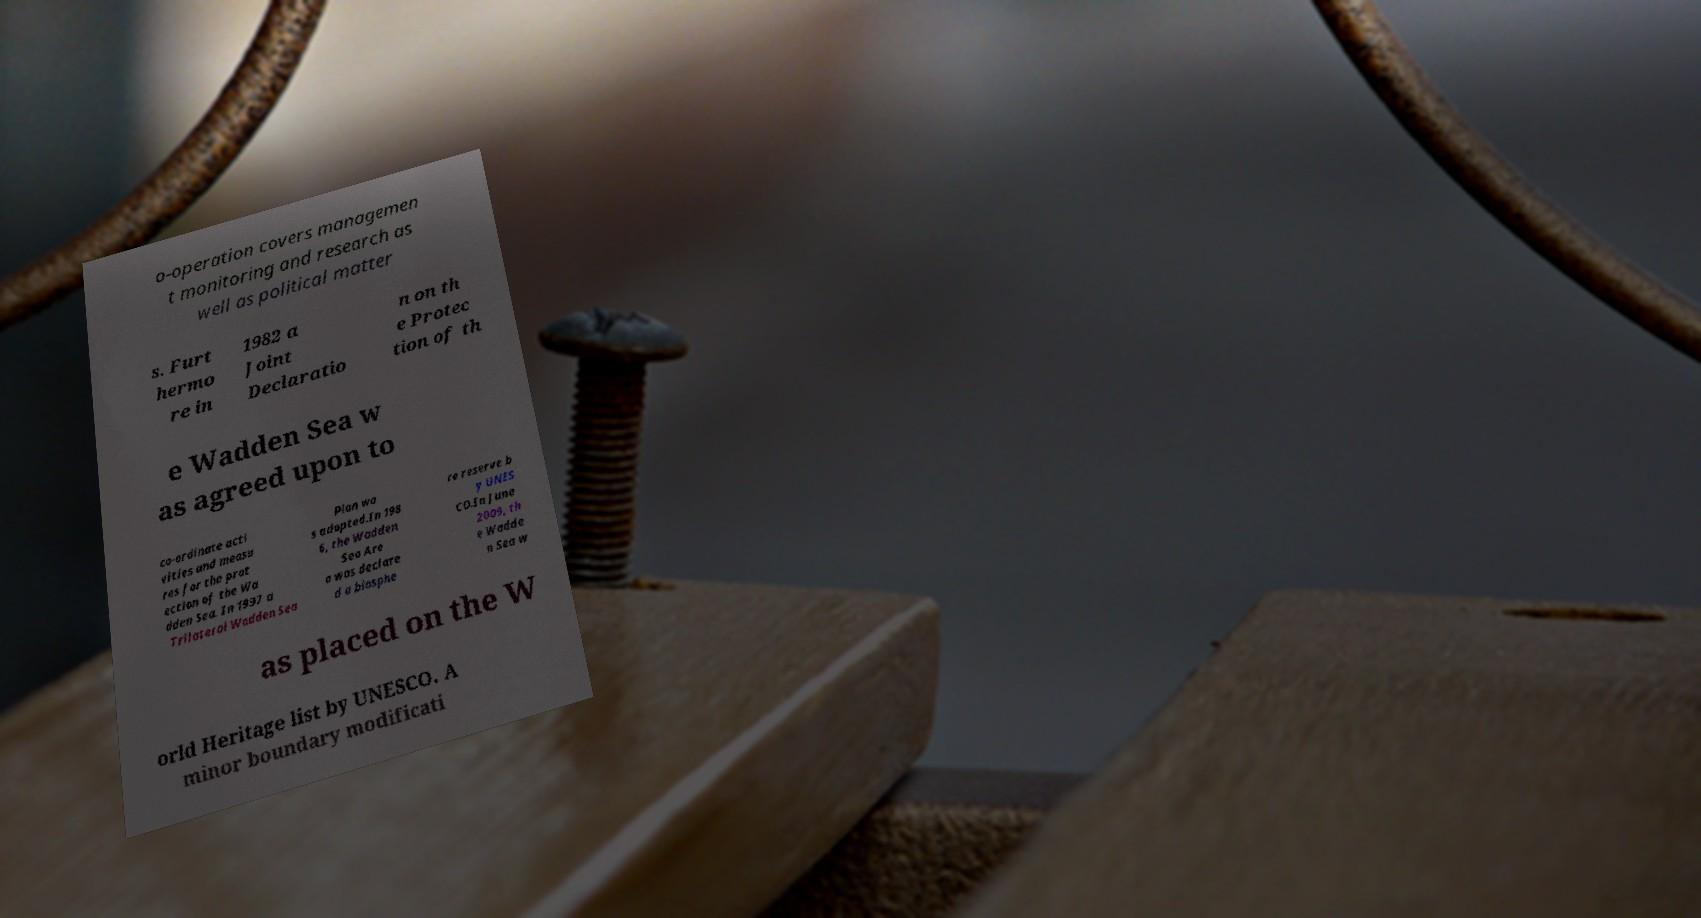What messages or text are displayed in this image? I need them in a readable, typed format. o-operation covers managemen t monitoring and research as well as political matter s. Furt hermo re in 1982 a Joint Declaratio n on th e Protec tion of th e Wadden Sea w as agreed upon to co-ordinate acti vities and measu res for the prot ection of the Wa dden Sea. In 1997 a Trilateral Wadden Sea Plan wa s adopted.In 198 6, the Wadden Sea Are a was declare d a biosphe re reserve b y UNES CO.In June 2009, th e Wadde n Sea w as placed on the W orld Heritage list by UNESCO. A minor boundary modificati 